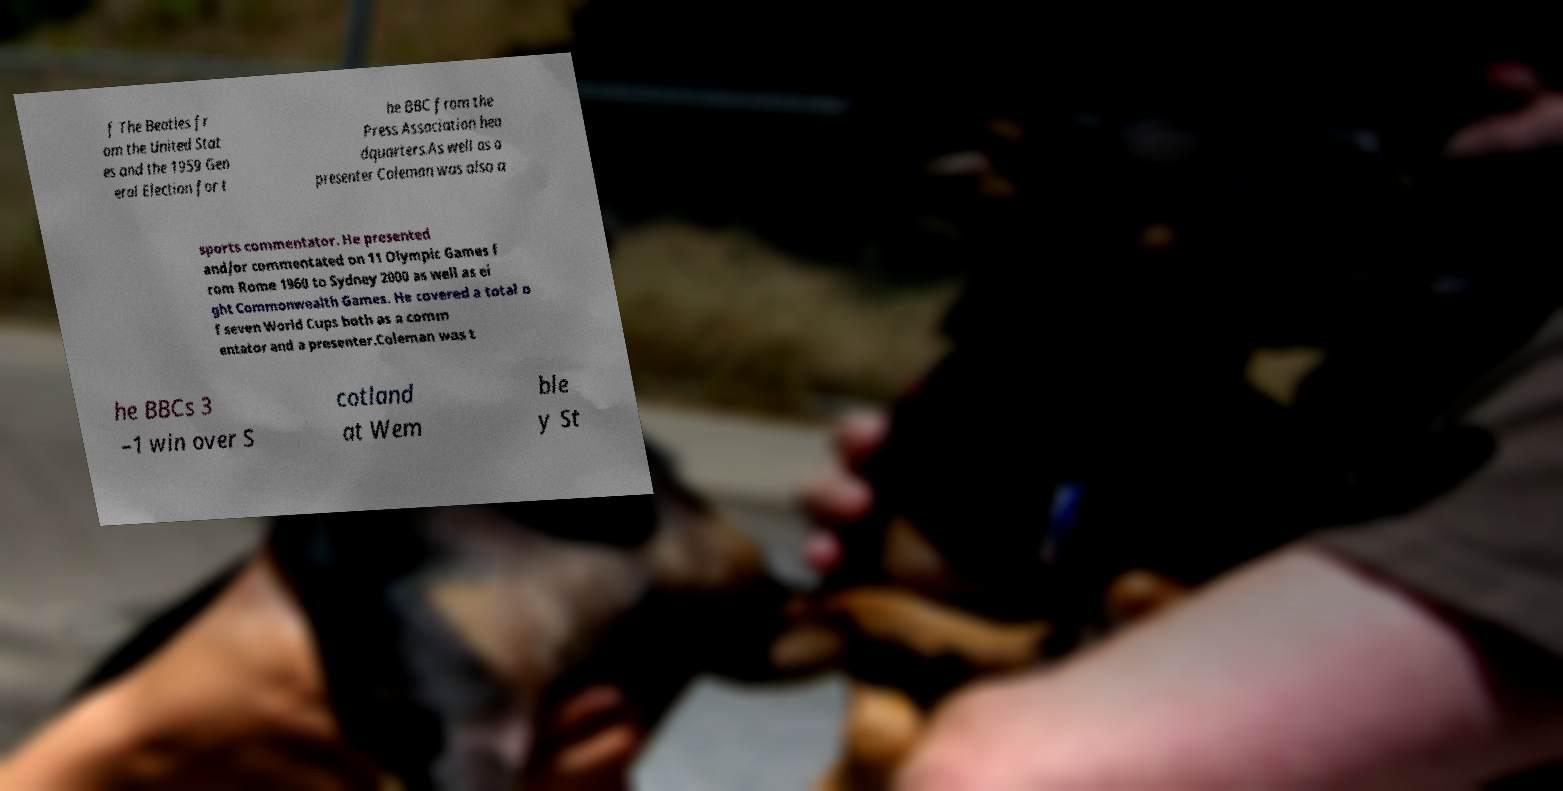Could you extract and type out the text from this image? f The Beatles fr om the United Stat es and the 1959 Gen eral Election for t he BBC from the Press Association hea dquarters.As well as a presenter Coleman was also a sports commentator. He presented and/or commentated on 11 Olympic Games f rom Rome 1960 to Sydney 2000 as well as ei ght Commonwealth Games. He covered a total o f seven World Cups both as a comm entator and a presenter.Coleman was t he BBCs 3 –1 win over S cotland at Wem ble y St 